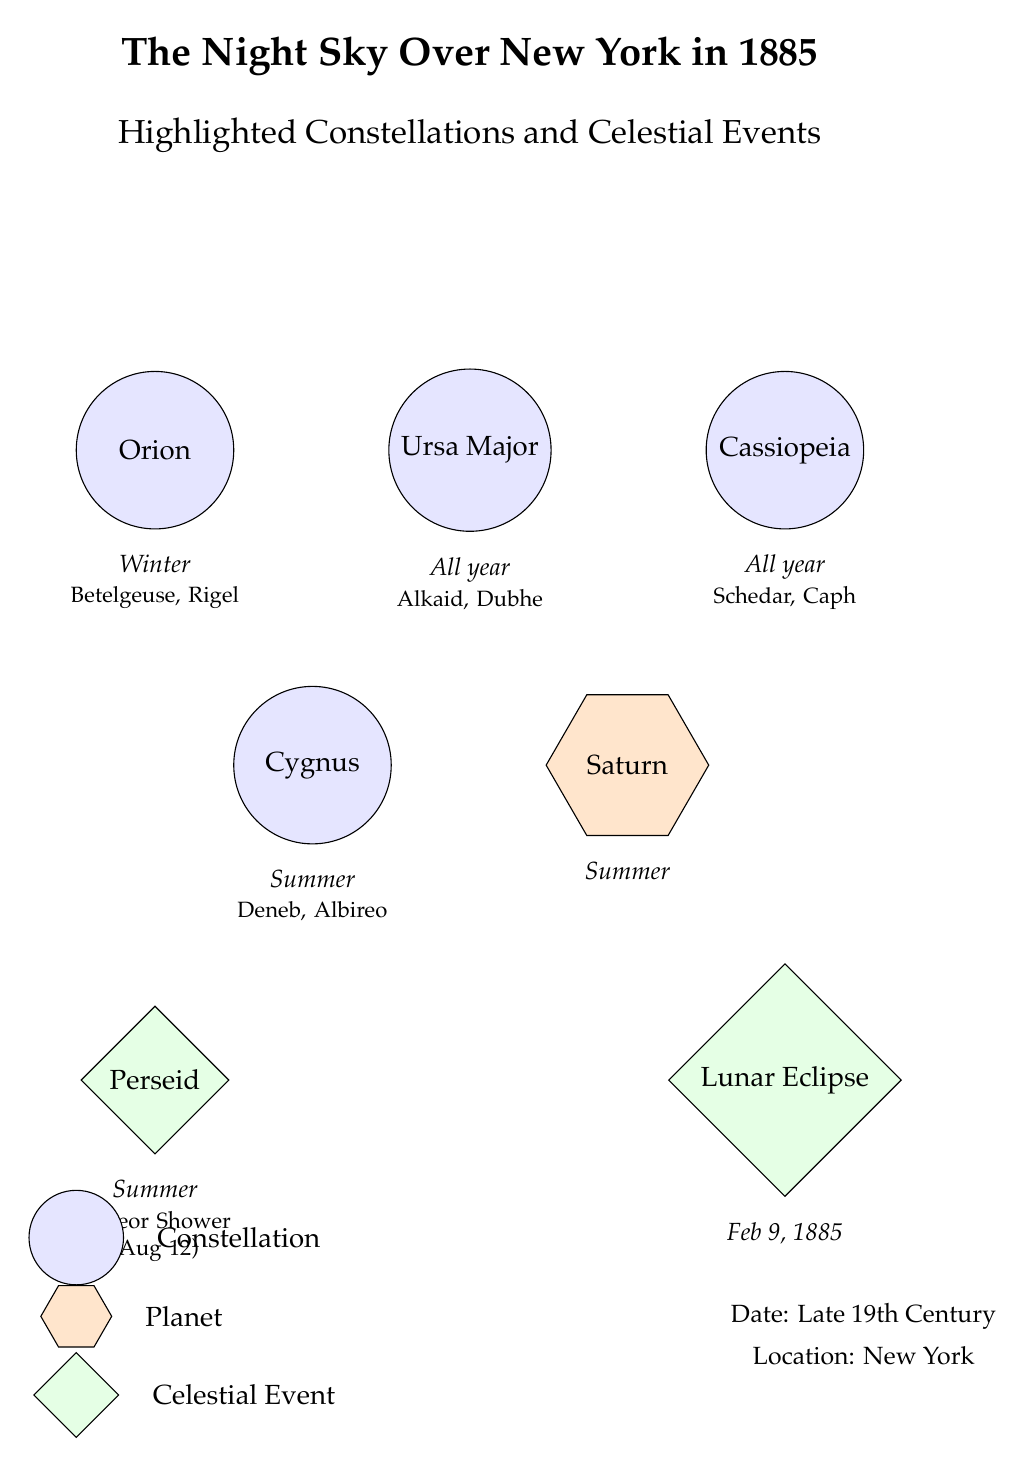What is the name of the constellation located at the top left? The constellation in the top left is labeled Orion. By directly referencing the diagram, we see the node specifically states "Orion" in that location.
Answer: Orion How many constellations are shown in the diagram? The diagram displays a total of five constellations: Orion, Ursa Major, Cassiopeia, Cygnus, and the planet label, but they count as constellations in a stellar context. Thus, we sum them to arrive at five.
Answer: 5 What celestial event occurs on February 9, 1885? The diagram specifically labels the event occurring on February 9, 1885, as "Lunar Eclipse." By identifying the node related to that date, we can confirm the event.
Answer: Lunar Eclipse Which constellation is associated with the stars Betelgeuse and Rigel? Betelgeuse and Rigel are specifically mentioned as notable stars in the Orion constellation, as indicated in the notes below the Orion label, referencing their relationship.
Answer: Orion What celestial event is described as a meteor shower? The "Perseid," described as a meteor shower taking place on August 12, is noted at the bottom left of the diagram, referencing the specific celestial event.
Answer: Perseid Which constellation is visible all year round? Two constellations, Ursa Major and Cassiopeia, are both labeled as being visible all year. Consulting the respective labels directly next to each constellation clarifies their availability.
Answer: Ursa Major, Cassiopeia What type of celestial feature is Saturn categorized as in the diagram? Saturn is represented as a "Planet" in the diagram, indicated by the specific shape and coloration designated for planets. The label directly describes it as such.
Answer: Planet During which season is Cygnus observed? The position of Cygnus in the diagram indicates that it is observed in "Summer," which is referenced directly below the constellation's name.
Answer: Summer How is the "Perseid" meteor shower described in terms of events? The "Perseid" meteor shower is characterized as a celestial event that occurs in "Summer," linked by the labels in that section of the diagram.
Answer: Summer 